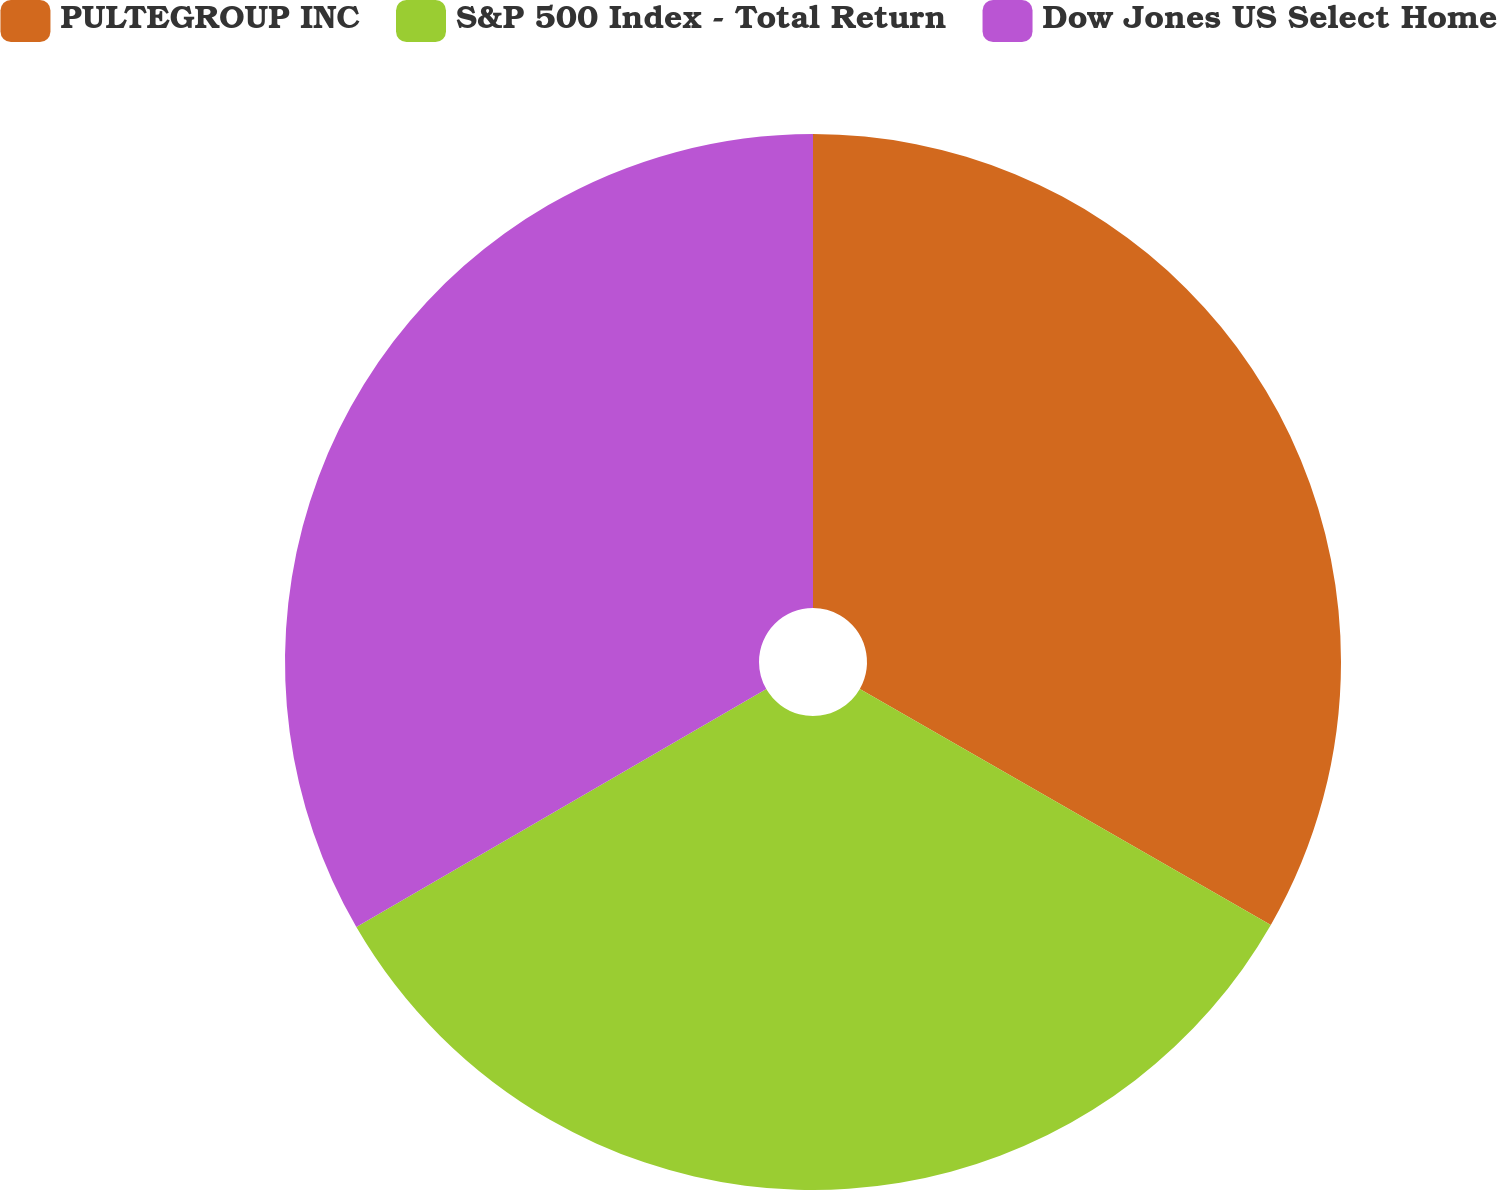Convert chart. <chart><loc_0><loc_0><loc_500><loc_500><pie_chart><fcel>PULTEGROUP INC<fcel>S&P 500 Index - Total Return<fcel>Dow Jones US Select Home<nl><fcel>33.3%<fcel>33.33%<fcel>33.37%<nl></chart> 